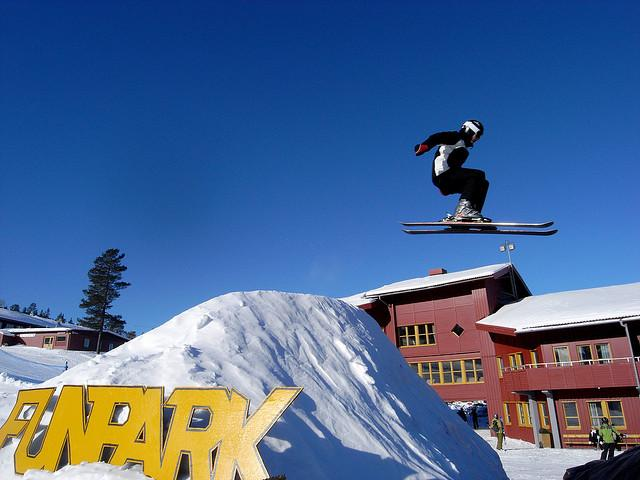What type of sign is shown? Please explain your reasoning. location. Based on the words visible, they sign is likely labelling the place that it is situated in. 